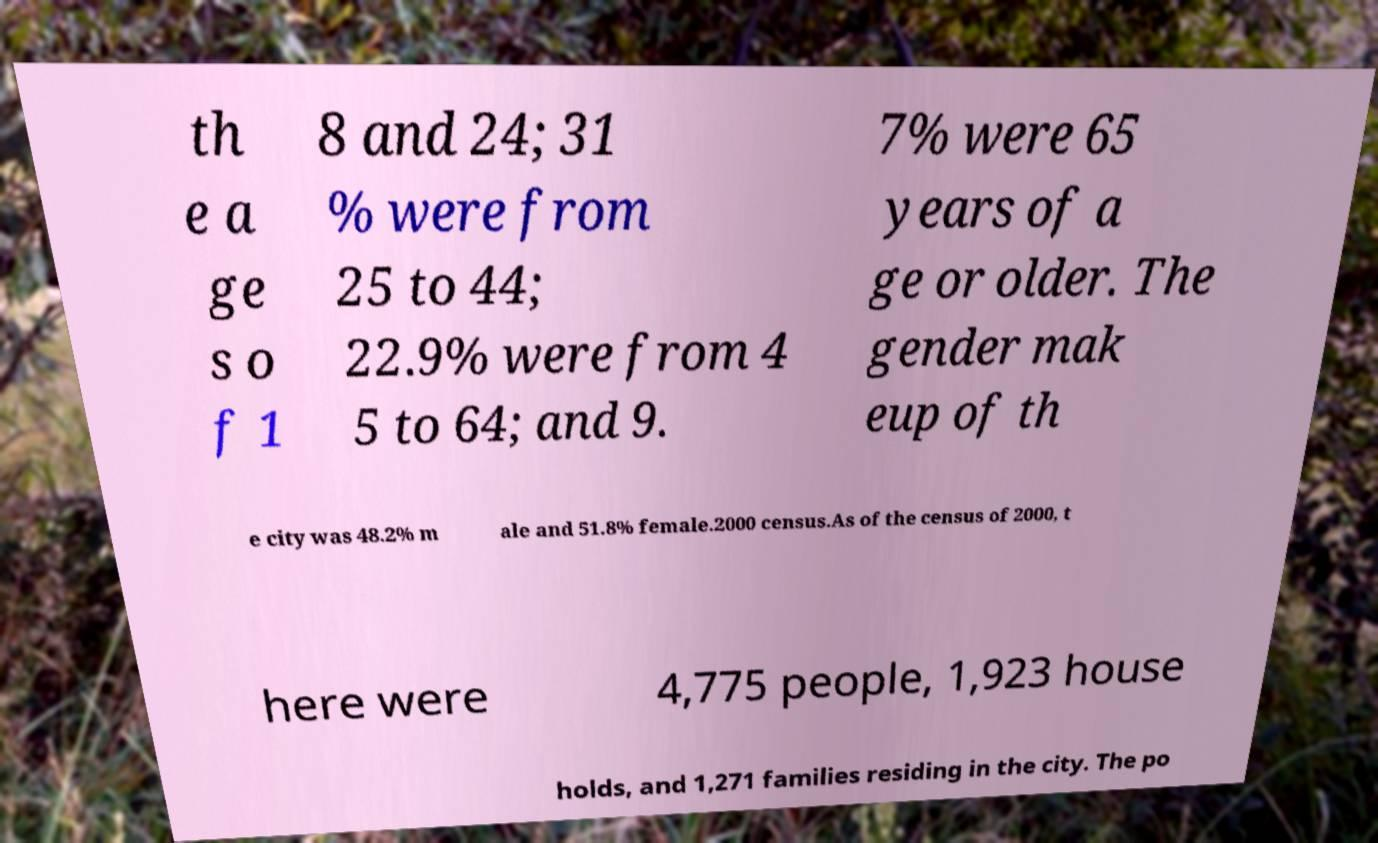Can you accurately transcribe the text from the provided image for me? th e a ge s o f 1 8 and 24; 31 % were from 25 to 44; 22.9% were from 4 5 to 64; and 9. 7% were 65 years of a ge or older. The gender mak eup of th e city was 48.2% m ale and 51.8% female.2000 census.As of the census of 2000, t here were 4,775 people, 1,923 house holds, and 1,271 families residing in the city. The po 